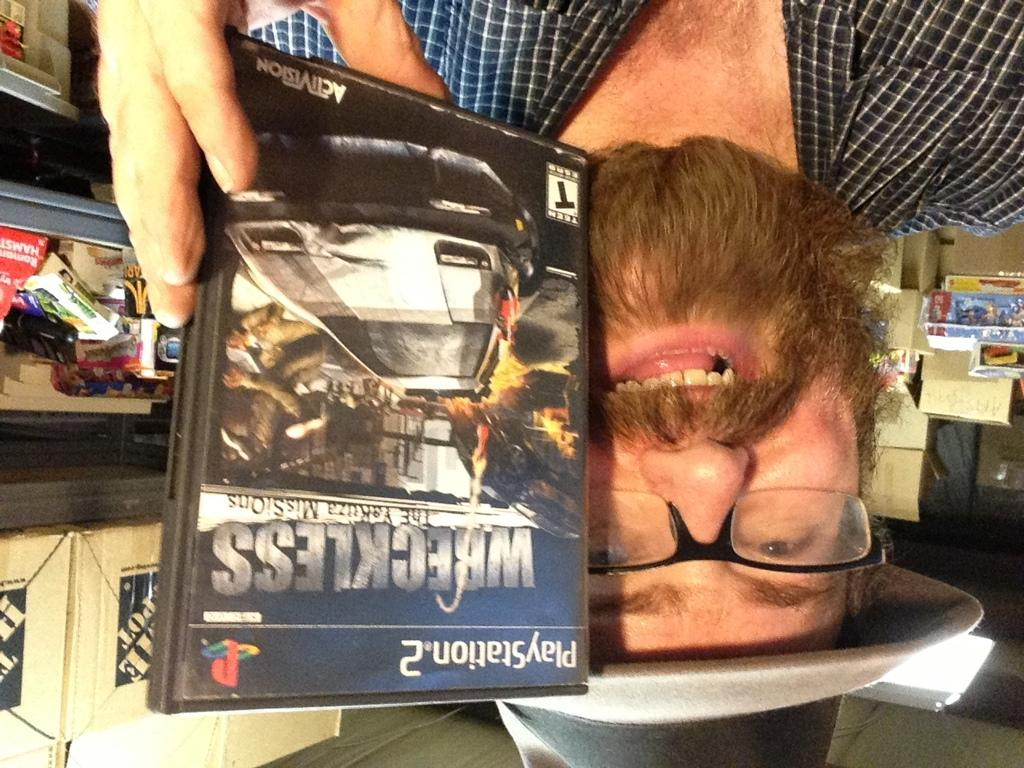What is the main subject of the image? There is a person in the image. What is the person wearing? The person is wearing a shirt. What is the person holding in their hand? The person is holding a CD with one hand. What is the facial expression of the person? The person is smiling. What can be seen in the background of the image? There are objects on a shelf and boxes in the background. How many sticks are visible in the image? There are no sticks visible in the image. What type of books can be seen on the shelf in the background? There are no books visible in the image; only objects on the shelf and boxes in the background. 